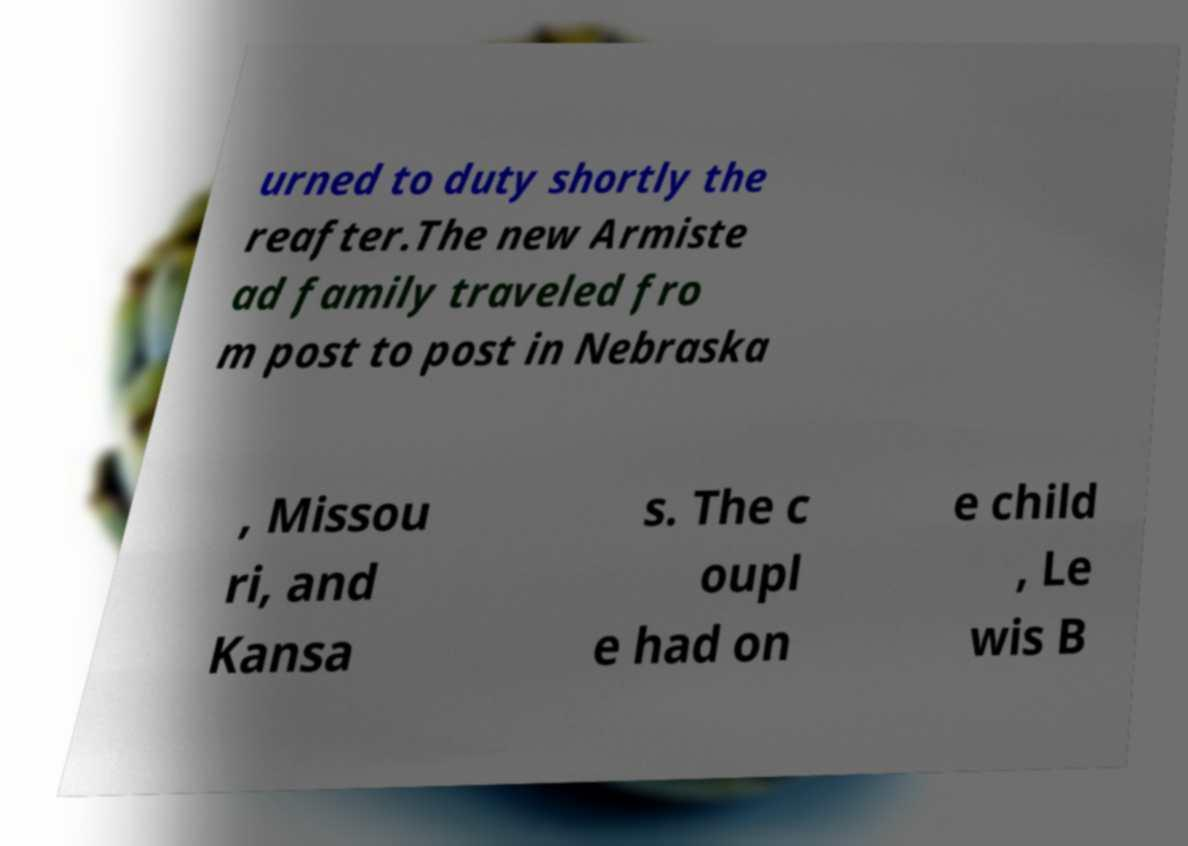What messages or text are displayed in this image? I need them in a readable, typed format. urned to duty shortly the reafter.The new Armiste ad family traveled fro m post to post in Nebraska , Missou ri, and Kansa s. The c oupl e had on e child , Le wis B 